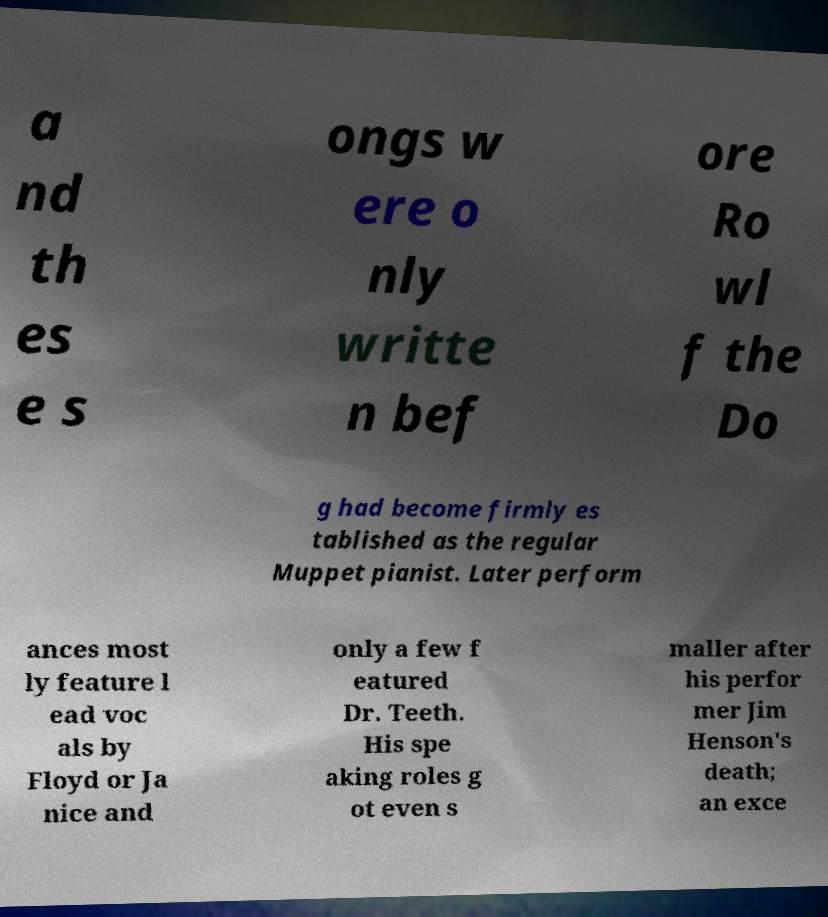Can you read and provide the text displayed in the image?This photo seems to have some interesting text. Can you extract and type it out for me? a nd th es e s ongs w ere o nly writte n bef ore Ro wl f the Do g had become firmly es tablished as the regular Muppet pianist. Later perform ances most ly feature l ead voc als by Floyd or Ja nice and only a few f eatured Dr. Teeth. His spe aking roles g ot even s maller after his perfor mer Jim Henson's death; an exce 